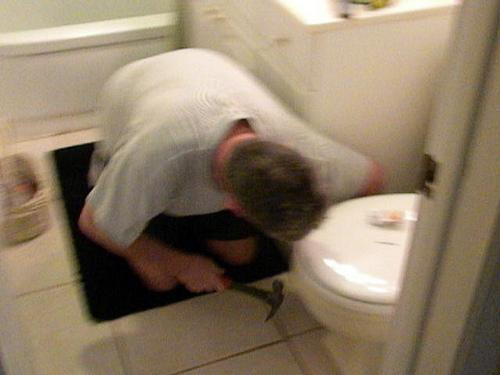Briefly depict the image focusing on the person and the room they are in. A man is kneeling and fixing a toilet in a dimly lit bathroom with white tiles, holding a hammer with an orange handle. Describe the actions of the man in the image and the items he's interacting with. The man in the image is kneeling on a black rug, repairing a white toilet using a red-handled hammer, and surrounded by white tiled flooring. Point out the main activity and the important elements related to the person in the image. The man is fixing a broken toilet while kneeling on a black bathroom rug, wearing a grey shirt, holding a red and black hammer, and surrounded by white tiles. Mention the key elements of the image along with their associated colors. The image includes a man fixing a white toilet, a grey shirt, khaki pants, a red-handled hammer, black bathroom rug, white tiles, and a white bathroom cabinet. Describe the main colors and objects featured in the bathroom scene. The bathroom scene features a white toilet, grey shirt, khaki pants, white tiles, a red and black hammer, black rug, and a white bathroom cabinet. In one sentence, describe the primary action being performed in the image. A man is repairing a white toilet while holding a hammer with an orange handle and kneeling on a black rug. Provide a brief description of the scene in the image. A man is kneeling on a black bathroom rug, fixing a white toilet, while holding a red-handled hammer in his right hand and wearing a grey shirt and khaki pants. What is the man doing and what tools is he using? The man is repairing a white toilet, using a red-handled hammer, while kneeling on a black bathroom rug. Explain what the person in the image is doing while highlighting their outfit. A man, wearing a grey shirt and khaki pants, is kneeling on a black bathroom rug and fixing a white toilet with the aid of a red-handled hammer. Explain the scene in the image, emphasizing the person's posture and surroundings. A man, bending over and kneeling on a black rug, is fixing a white toilet in a bathroom with white tiles, holding a hammer with an orange handle. 